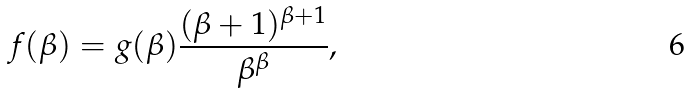Convert formula to latex. <formula><loc_0><loc_0><loc_500><loc_500>f ( \beta ) = g ( \beta ) \frac { ( \beta + 1 ) ^ { \beta + 1 } } { \beta ^ { \beta } } ,</formula> 